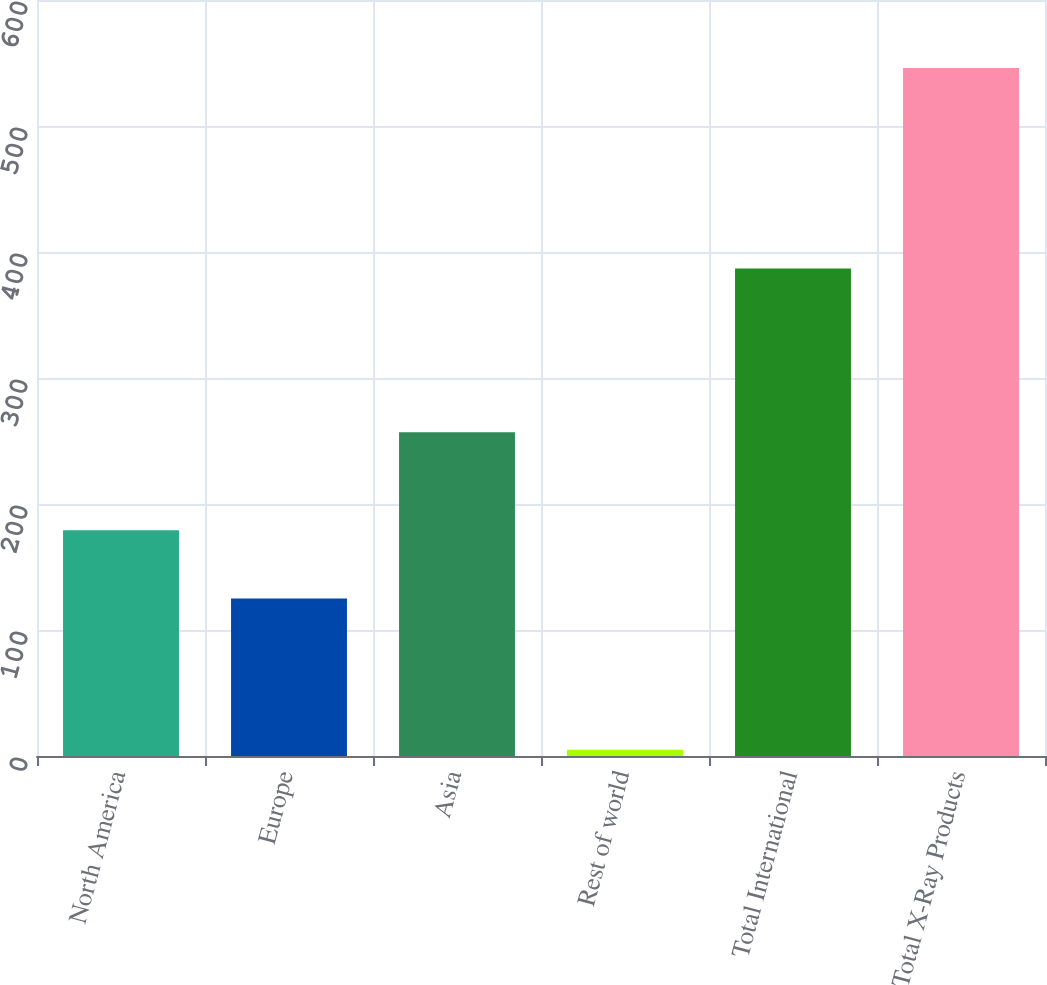Convert chart. <chart><loc_0><loc_0><loc_500><loc_500><bar_chart><fcel>North America<fcel>Europe<fcel>Asia<fcel>Rest of world<fcel>Total International<fcel>Total X-Ray Products<nl><fcel>179.1<fcel>125<fcel>257<fcel>5<fcel>387<fcel>546<nl></chart> 